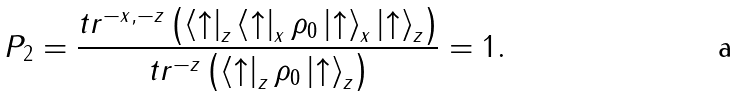Convert formula to latex. <formula><loc_0><loc_0><loc_500><loc_500>P _ { 2 } = \frac { t r ^ { - x , - z } \left ( \left < \uparrow \right | _ { z } \left < \uparrow \right | _ { x } \rho _ { 0 } \left | \uparrow \right > _ { x } \left | \uparrow \right > _ { z } \right ) } { t r ^ { - z } \left ( \left < \uparrow \right | _ { z } \rho _ { 0 } \left | \uparrow \right > _ { z } \right ) } = 1 .</formula> 